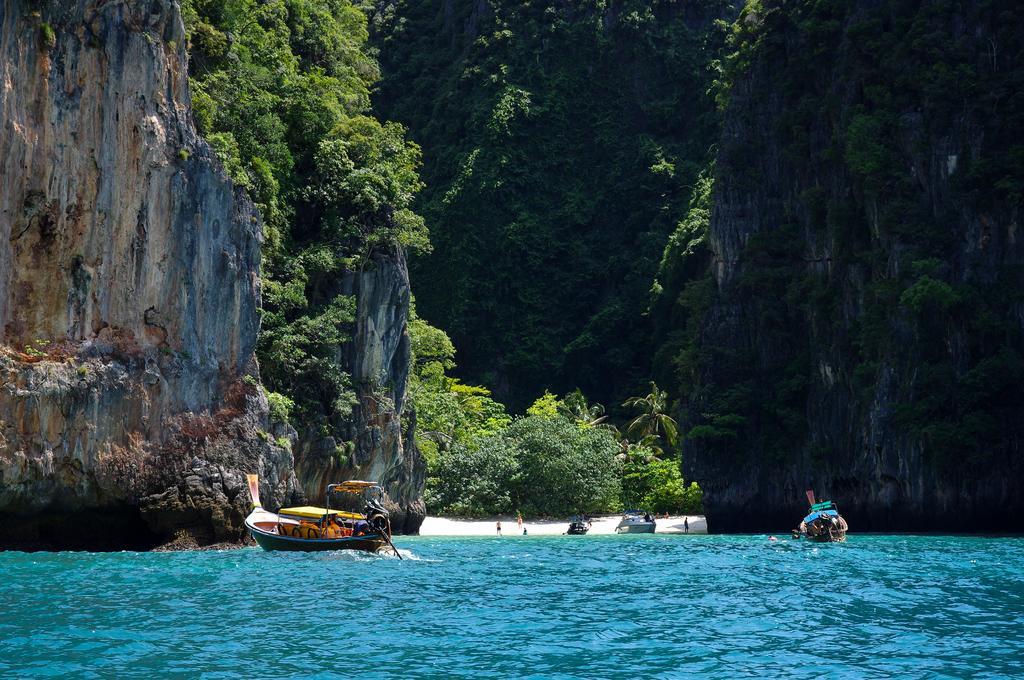How would you summarize this image in a sentence or two? In this image, we can see some mountains, trees, boats, few people are inside the boat, few are in the middle. At the bottom, we can see sea. 